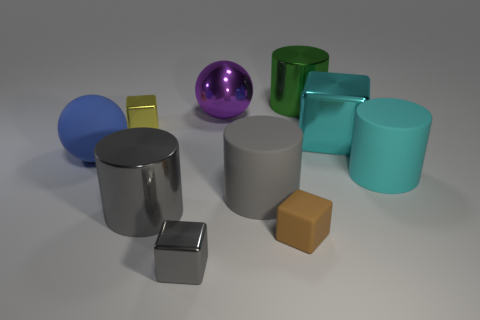Subtract 1 cylinders. How many cylinders are left? 3 Subtract all cylinders. How many objects are left? 6 Subtract 0 red balls. How many objects are left? 10 Subtract all cyan blocks. Subtract all tiny yellow things. How many objects are left? 8 Add 8 big cyan matte things. How many big cyan matte things are left? 9 Add 4 red shiny things. How many red shiny things exist? 4 